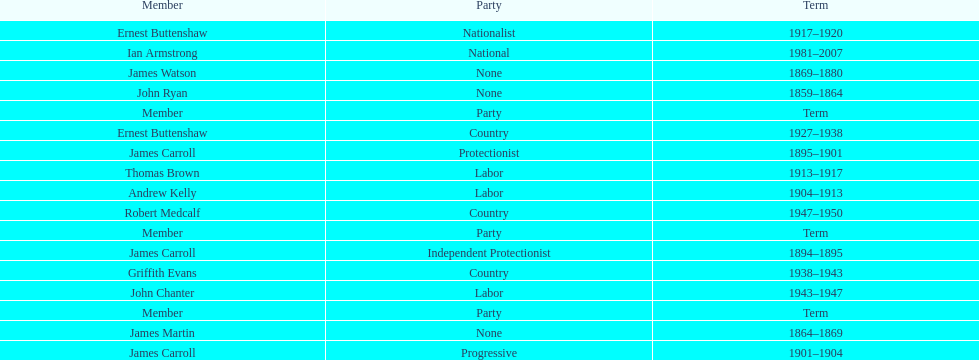How long did ian armstrong serve? 26 years. Parse the table in full. {'header': ['Member', 'Party', 'Term'], 'rows': [['Ernest Buttenshaw', 'Nationalist', '1917–1920'], ['Ian Armstrong', 'National', '1981–2007'], ['James Watson', 'None', '1869–1880'], ['John Ryan', 'None', '1859–1864'], ['Member', 'Party', 'Term'], ['Ernest Buttenshaw', 'Country', '1927–1938'], ['James Carroll', 'Protectionist', '1895–1901'], ['Thomas Brown', 'Labor', '1913–1917'], ['Andrew Kelly', 'Labor', '1904–1913'], ['Robert Medcalf', 'Country', '1947–1950'], ['Member', 'Party', 'Term'], ['James Carroll', 'Independent Protectionist', '1894–1895'], ['Griffith Evans', 'Country', '1938–1943'], ['John Chanter', 'Labor', '1943–1947'], ['Member', 'Party', 'Term'], ['James Martin', 'None', '1864–1869'], ['James Carroll', 'Progressive', '1901–1904']]} 